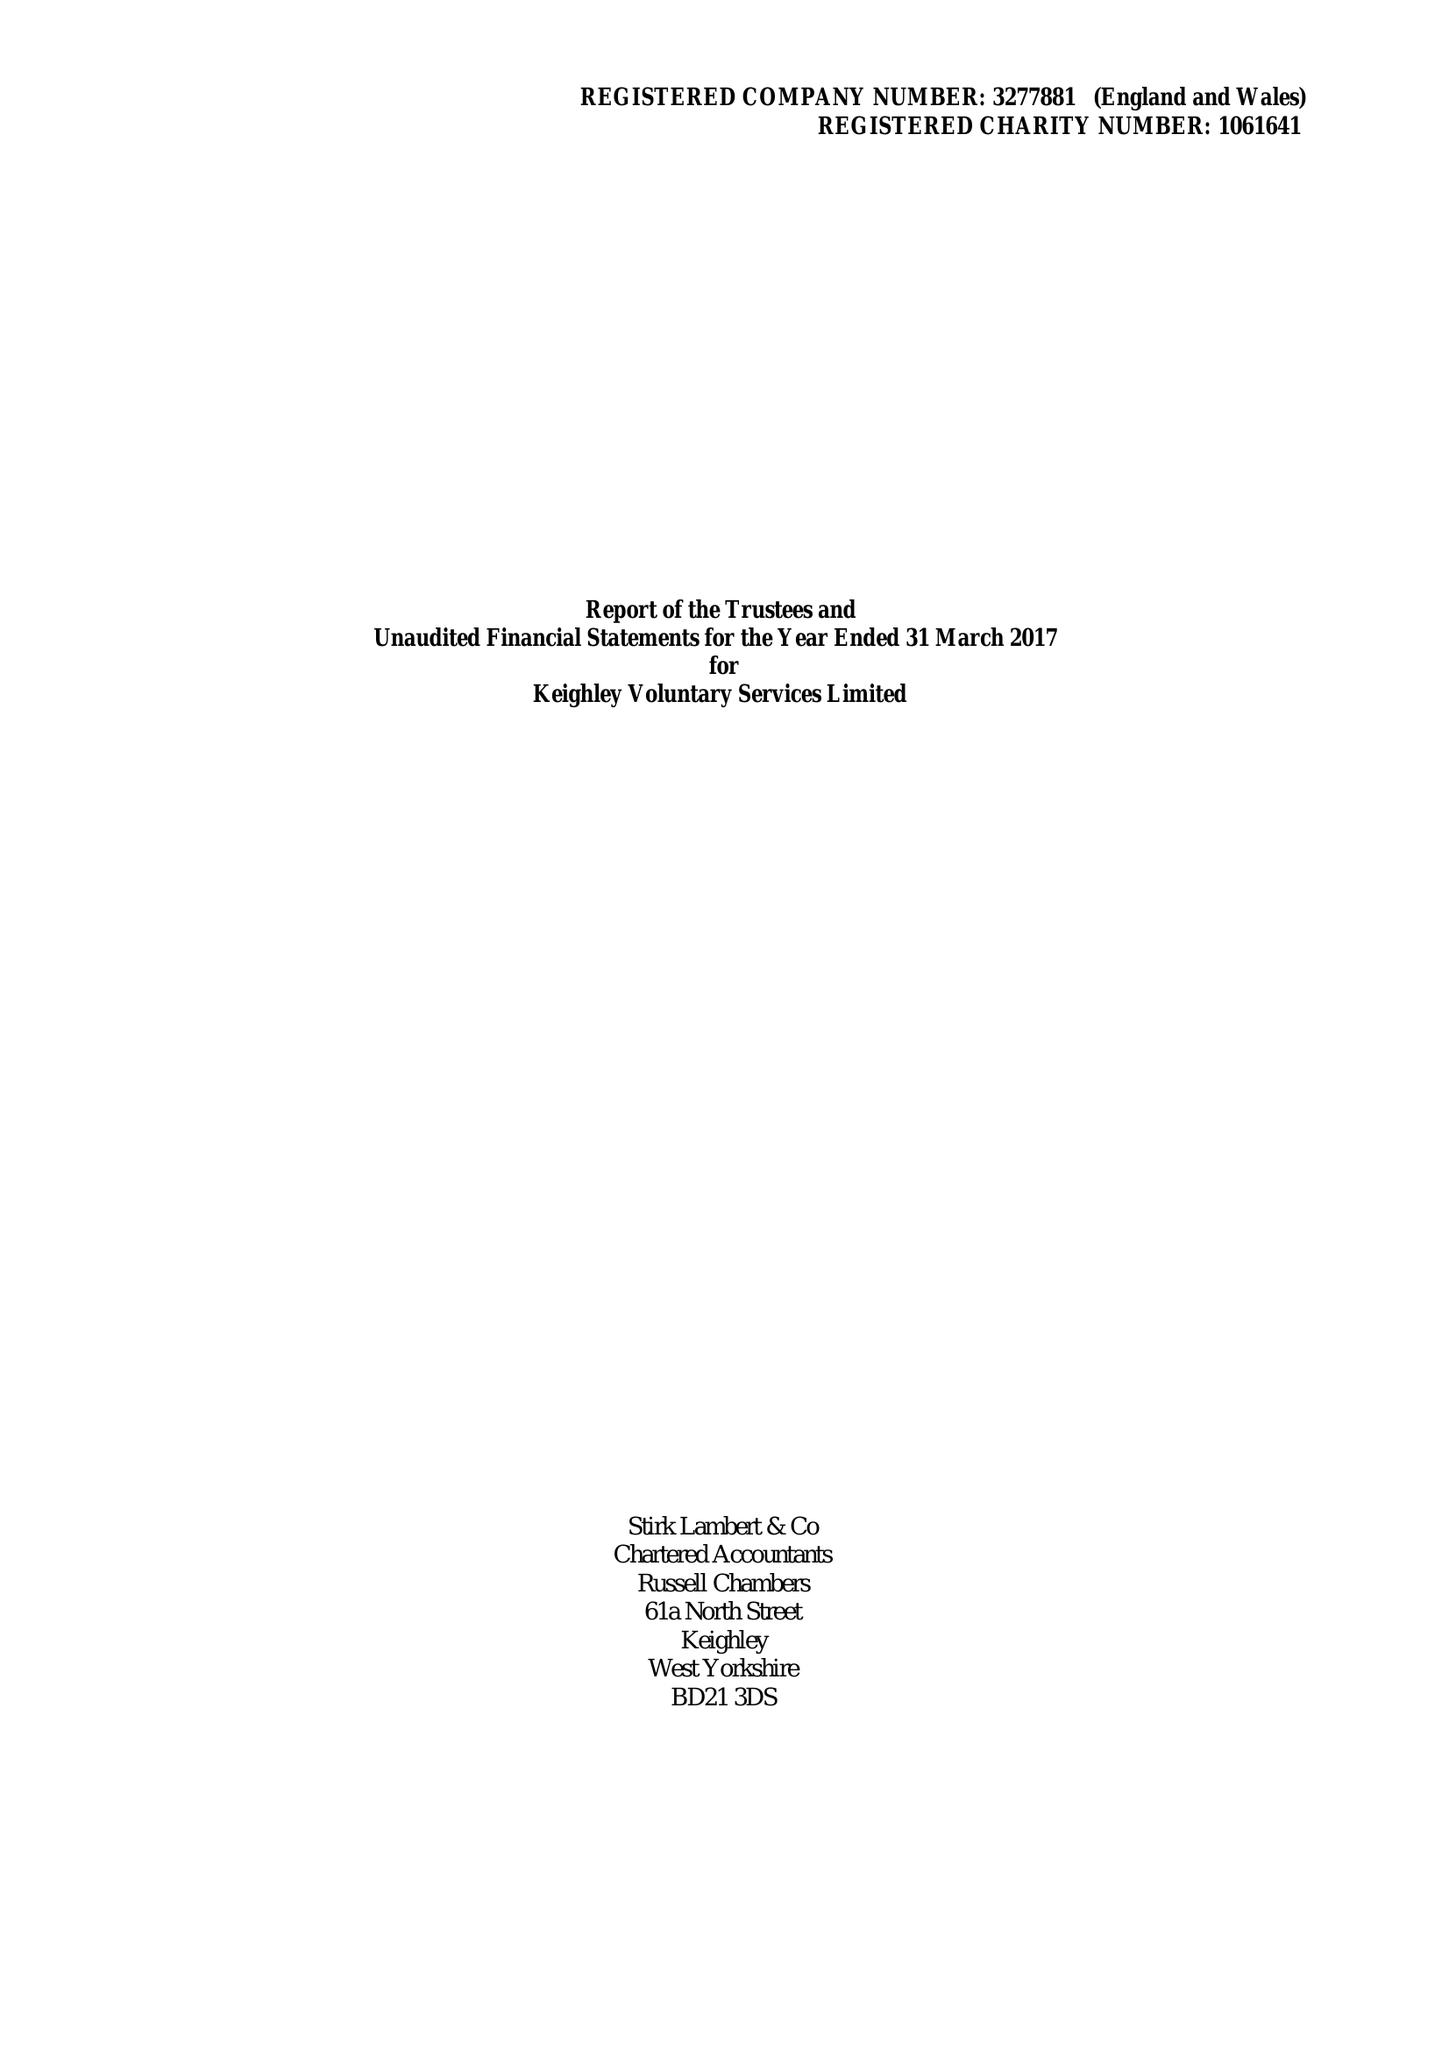What is the value for the spending_annually_in_british_pounds?
Answer the question using a single word or phrase. 541745.00 